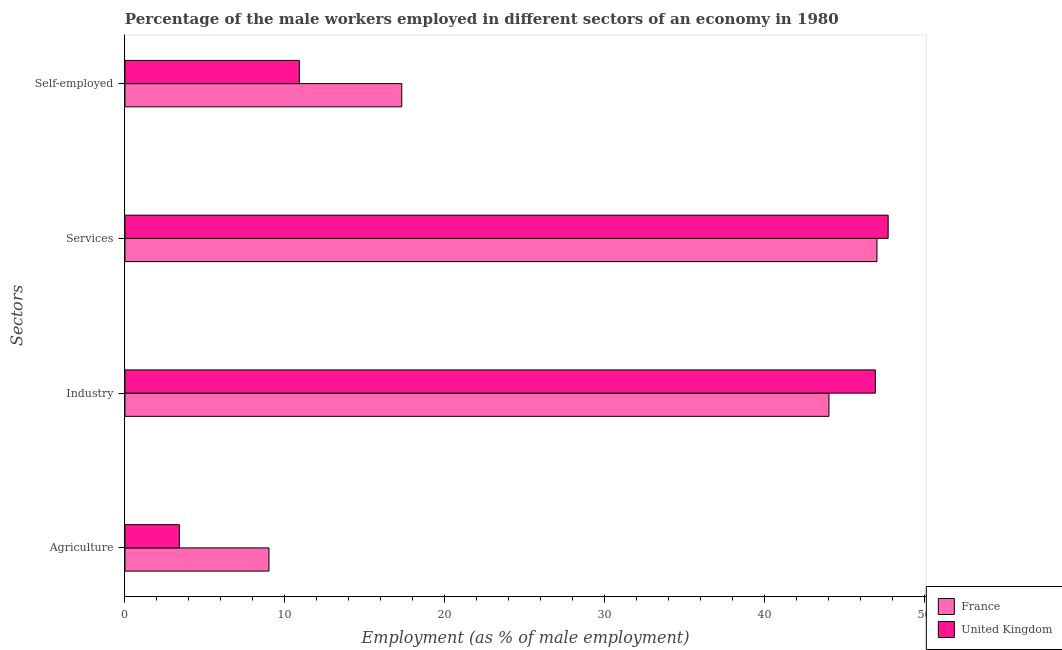Are the number of bars per tick equal to the number of legend labels?
Give a very brief answer. Yes. How many bars are there on the 1st tick from the top?
Your response must be concise. 2. How many bars are there on the 1st tick from the bottom?
Give a very brief answer. 2. What is the label of the 1st group of bars from the top?
Provide a succinct answer. Self-employed. What is the percentage of male workers in services in France?
Your answer should be compact. 47. Across all countries, what is the maximum percentage of male workers in industry?
Give a very brief answer. 46.9. Across all countries, what is the minimum percentage of male workers in industry?
Make the answer very short. 44. What is the total percentage of male workers in industry in the graph?
Your answer should be very brief. 90.9. What is the difference between the percentage of male workers in services in United Kingdom and that in France?
Make the answer very short. 0.7. What is the difference between the percentage of male workers in agriculture in United Kingdom and the percentage of male workers in industry in France?
Offer a very short reply. -40.6. What is the average percentage of male workers in industry per country?
Offer a terse response. 45.45. What is the difference between the percentage of self employed male workers and percentage of male workers in agriculture in France?
Offer a terse response. 8.3. In how many countries, is the percentage of male workers in services greater than 38 %?
Make the answer very short. 2. What is the ratio of the percentage of self employed male workers in France to that in United Kingdom?
Your answer should be compact. 1.59. What is the difference between the highest and the second highest percentage of male workers in industry?
Ensure brevity in your answer.  2.9. What is the difference between the highest and the lowest percentage of male workers in agriculture?
Provide a succinct answer. 5.6. In how many countries, is the percentage of male workers in services greater than the average percentage of male workers in services taken over all countries?
Make the answer very short. 1. Is the sum of the percentage of self employed male workers in France and United Kingdom greater than the maximum percentage of male workers in services across all countries?
Provide a succinct answer. No. Is it the case that in every country, the sum of the percentage of male workers in agriculture and percentage of self employed male workers is greater than the sum of percentage of male workers in industry and percentage of male workers in services?
Make the answer very short. No. How many bars are there?
Your response must be concise. 8. Are all the bars in the graph horizontal?
Offer a very short reply. Yes. How many countries are there in the graph?
Your answer should be very brief. 2. What is the difference between two consecutive major ticks on the X-axis?
Your response must be concise. 10. Does the graph contain any zero values?
Offer a very short reply. No. Does the graph contain grids?
Give a very brief answer. No. How many legend labels are there?
Give a very brief answer. 2. How are the legend labels stacked?
Your response must be concise. Vertical. What is the title of the graph?
Your answer should be very brief. Percentage of the male workers employed in different sectors of an economy in 1980. Does "Syrian Arab Republic" appear as one of the legend labels in the graph?
Your answer should be very brief. No. What is the label or title of the X-axis?
Ensure brevity in your answer.  Employment (as % of male employment). What is the label or title of the Y-axis?
Your answer should be compact. Sectors. What is the Employment (as % of male employment) of United Kingdom in Agriculture?
Keep it short and to the point. 3.4. What is the Employment (as % of male employment) in France in Industry?
Give a very brief answer. 44. What is the Employment (as % of male employment) in United Kingdom in Industry?
Give a very brief answer. 46.9. What is the Employment (as % of male employment) in United Kingdom in Services?
Give a very brief answer. 47.7. What is the Employment (as % of male employment) in France in Self-employed?
Ensure brevity in your answer.  17.3. What is the Employment (as % of male employment) of United Kingdom in Self-employed?
Make the answer very short. 10.9. Across all Sectors, what is the maximum Employment (as % of male employment) of France?
Keep it short and to the point. 47. Across all Sectors, what is the maximum Employment (as % of male employment) of United Kingdom?
Offer a very short reply. 47.7. Across all Sectors, what is the minimum Employment (as % of male employment) of France?
Give a very brief answer. 9. Across all Sectors, what is the minimum Employment (as % of male employment) of United Kingdom?
Your response must be concise. 3.4. What is the total Employment (as % of male employment) of France in the graph?
Your answer should be very brief. 117.3. What is the total Employment (as % of male employment) in United Kingdom in the graph?
Your answer should be compact. 108.9. What is the difference between the Employment (as % of male employment) in France in Agriculture and that in Industry?
Provide a succinct answer. -35. What is the difference between the Employment (as % of male employment) of United Kingdom in Agriculture and that in Industry?
Your answer should be compact. -43.5. What is the difference between the Employment (as % of male employment) of France in Agriculture and that in Services?
Ensure brevity in your answer.  -38. What is the difference between the Employment (as % of male employment) of United Kingdom in Agriculture and that in Services?
Keep it short and to the point. -44.3. What is the difference between the Employment (as % of male employment) of France in Agriculture and that in Self-employed?
Provide a succinct answer. -8.3. What is the difference between the Employment (as % of male employment) of France in Industry and that in Services?
Make the answer very short. -3. What is the difference between the Employment (as % of male employment) of France in Industry and that in Self-employed?
Your response must be concise. 26.7. What is the difference between the Employment (as % of male employment) in France in Services and that in Self-employed?
Provide a short and direct response. 29.7. What is the difference between the Employment (as % of male employment) in United Kingdom in Services and that in Self-employed?
Make the answer very short. 36.8. What is the difference between the Employment (as % of male employment) of France in Agriculture and the Employment (as % of male employment) of United Kingdom in Industry?
Your response must be concise. -37.9. What is the difference between the Employment (as % of male employment) in France in Agriculture and the Employment (as % of male employment) in United Kingdom in Services?
Ensure brevity in your answer.  -38.7. What is the difference between the Employment (as % of male employment) in France in Industry and the Employment (as % of male employment) in United Kingdom in Services?
Offer a terse response. -3.7. What is the difference between the Employment (as % of male employment) in France in Industry and the Employment (as % of male employment) in United Kingdom in Self-employed?
Offer a terse response. 33.1. What is the difference between the Employment (as % of male employment) in France in Services and the Employment (as % of male employment) in United Kingdom in Self-employed?
Offer a terse response. 36.1. What is the average Employment (as % of male employment) of France per Sectors?
Keep it short and to the point. 29.32. What is the average Employment (as % of male employment) in United Kingdom per Sectors?
Give a very brief answer. 27.23. What is the difference between the Employment (as % of male employment) of France and Employment (as % of male employment) of United Kingdom in Agriculture?
Provide a succinct answer. 5.6. What is the difference between the Employment (as % of male employment) of France and Employment (as % of male employment) of United Kingdom in Industry?
Ensure brevity in your answer.  -2.9. What is the difference between the Employment (as % of male employment) of France and Employment (as % of male employment) of United Kingdom in Self-employed?
Ensure brevity in your answer.  6.4. What is the ratio of the Employment (as % of male employment) in France in Agriculture to that in Industry?
Give a very brief answer. 0.2. What is the ratio of the Employment (as % of male employment) in United Kingdom in Agriculture to that in Industry?
Your answer should be compact. 0.07. What is the ratio of the Employment (as % of male employment) of France in Agriculture to that in Services?
Give a very brief answer. 0.19. What is the ratio of the Employment (as % of male employment) in United Kingdom in Agriculture to that in Services?
Provide a succinct answer. 0.07. What is the ratio of the Employment (as % of male employment) of France in Agriculture to that in Self-employed?
Provide a short and direct response. 0.52. What is the ratio of the Employment (as % of male employment) in United Kingdom in Agriculture to that in Self-employed?
Offer a very short reply. 0.31. What is the ratio of the Employment (as % of male employment) of France in Industry to that in Services?
Your answer should be compact. 0.94. What is the ratio of the Employment (as % of male employment) in United Kingdom in Industry to that in Services?
Offer a terse response. 0.98. What is the ratio of the Employment (as % of male employment) in France in Industry to that in Self-employed?
Your response must be concise. 2.54. What is the ratio of the Employment (as % of male employment) of United Kingdom in Industry to that in Self-employed?
Offer a very short reply. 4.3. What is the ratio of the Employment (as % of male employment) in France in Services to that in Self-employed?
Your answer should be compact. 2.72. What is the ratio of the Employment (as % of male employment) in United Kingdom in Services to that in Self-employed?
Provide a succinct answer. 4.38. What is the difference between the highest and the second highest Employment (as % of male employment) of France?
Keep it short and to the point. 3. What is the difference between the highest and the second highest Employment (as % of male employment) in United Kingdom?
Your answer should be compact. 0.8. What is the difference between the highest and the lowest Employment (as % of male employment) of United Kingdom?
Offer a very short reply. 44.3. 